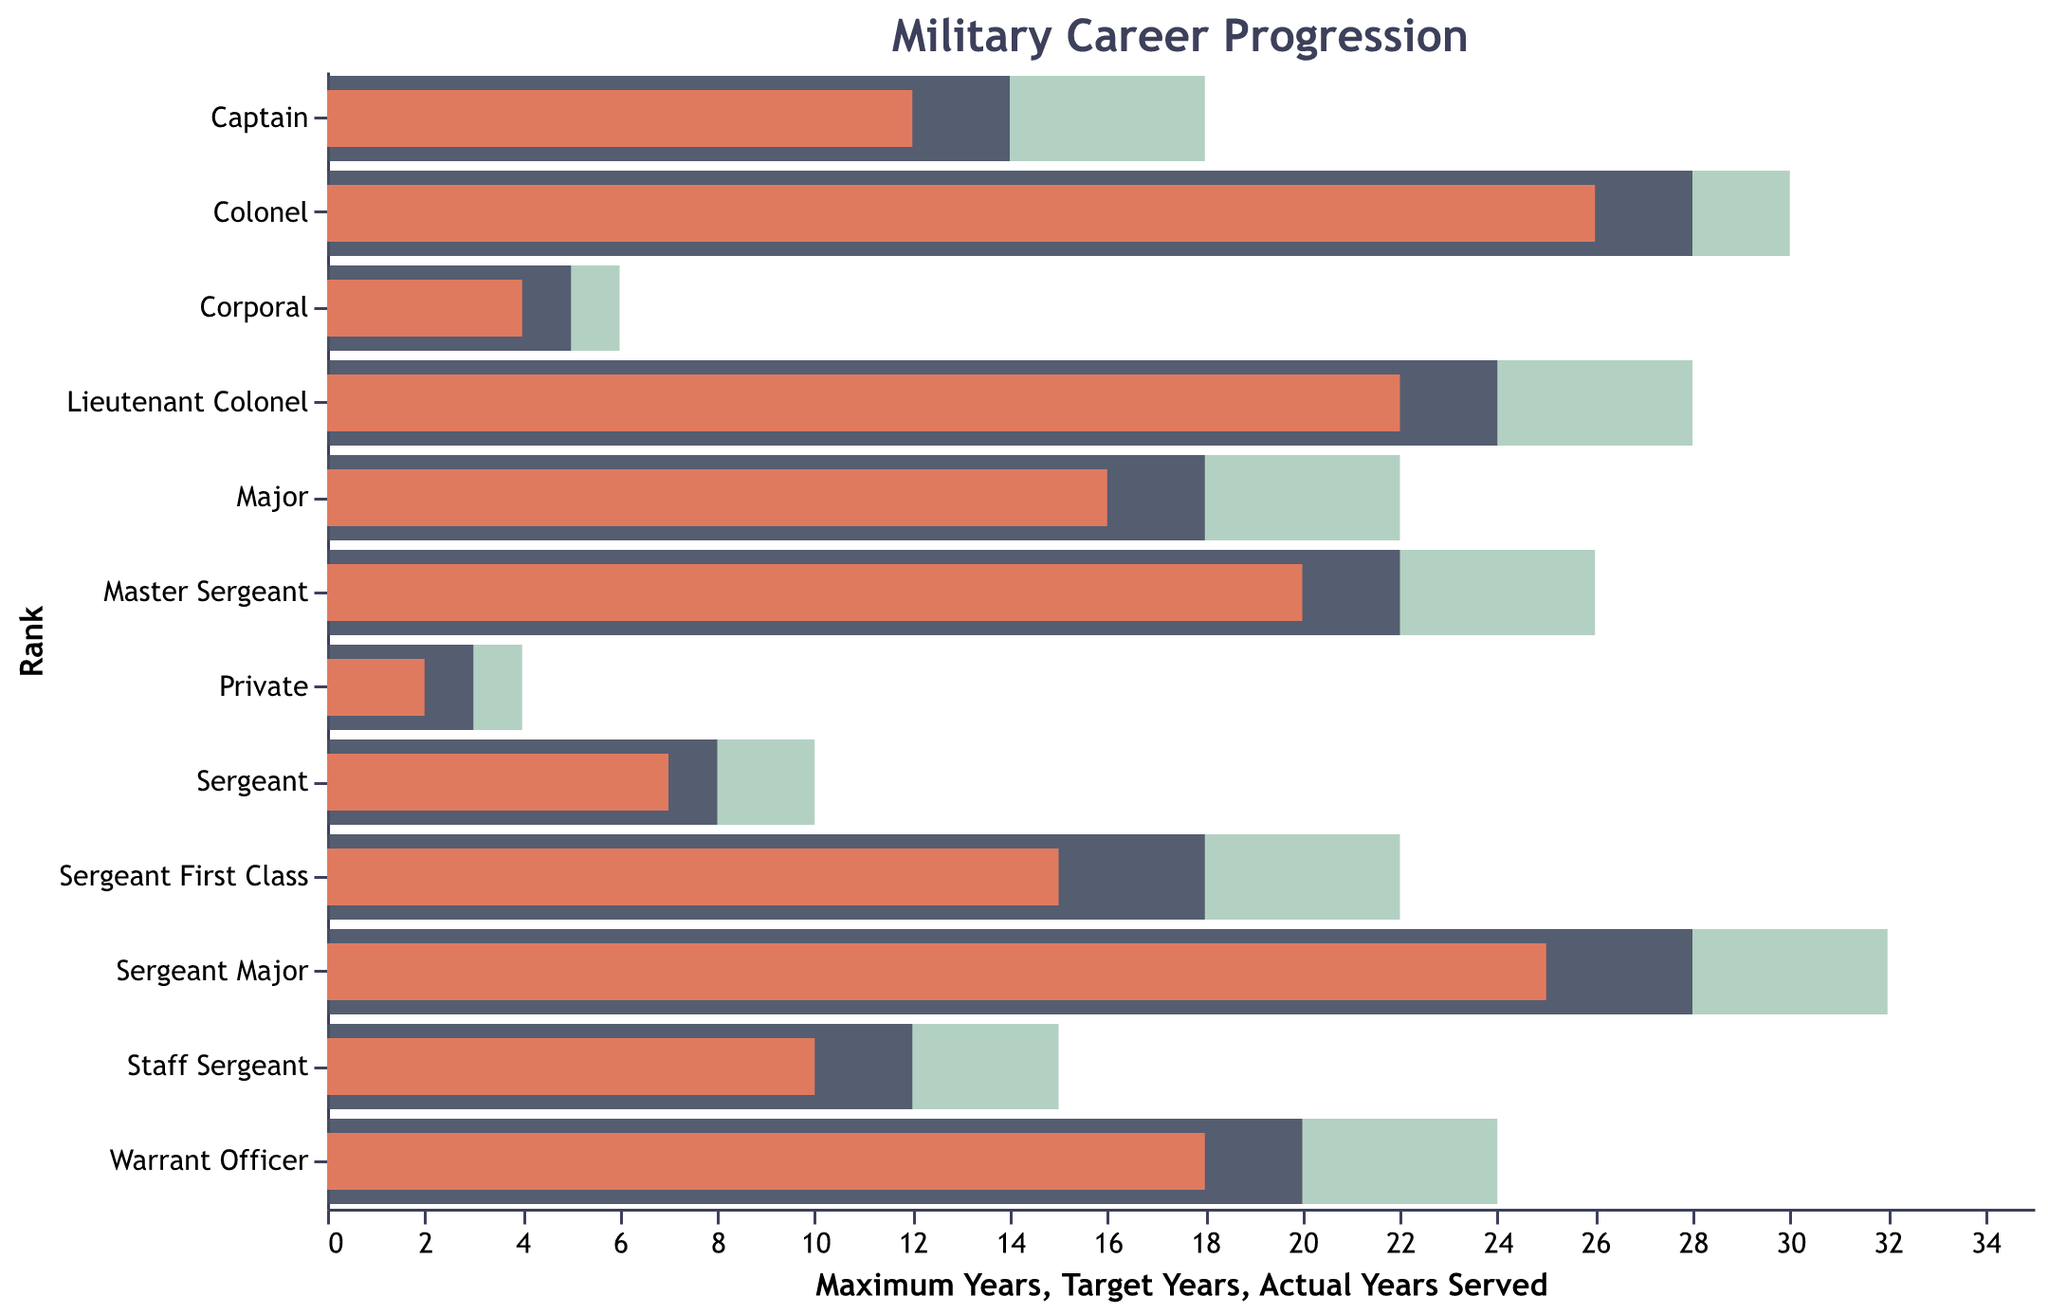What is the title of the chart? The title "Military Career Progression" is clearly displayed at the top of the chart in a larger font size.
Answer: Military Career Progression Which rank has the highest number of actual years served? The bar with the "Actual Years Served" value that stretches the farthest to the right represents the rank with the highest actual years served. For "Sergeant Major," the chart shows 25 years.
Answer: Sergeant Major What are the target years for a Major? Locate the "Major" row and find the length of the "Target Years" bar, which is marked by a darker shaded bar. For Major, it is 18 years.
Answer: 18 years How many actual years served does a Captain have, and how does it compare to its target years? Locate the "Captain" row, check the actual years served bar (12 years), and compare it with the target years bar (14 years).
Answer: Actual: 12 years, Target: 14 years How many ranks have more actual years served than their target years? Identify each rank where the "Actual Years Served" bar extends beyond the "Target Years" bar. These ranks are: Private, Corporal, and Sergeant.
Answer: 3 ranks Difference in years between the target and maximum years for Sergeant First Class? Subtract the target years from maximum years for "Sergeant First Class" (22 years - 18 years).
Answer: 4 years Which rank has the smallest difference between actual years served and target years? Compare the differences for each rank. "Private" has the smallest difference of 1 year (3 - 2 years).
Answer: Private What is the range of maximum years served within these ranks? Find the minimum and maximum values of "Maximum Years" across all ranks, which are 4 years (Private) and 32 years (Sergeant Major). The range is 32 - 4.
Answer: 28 years Does any rank have their actual years served equal to their target years? Check if any of the "Actual Years Served" bars align exactly with the "Target Years" bars. None of the ranks meet this criterion.
Answer: No Which rank has the highest maximum years, and how many years is it? Locate the tallest "Maximum Years" bar in the chart, for "Sergeant Major," indicating the highest maximum years served at 32 years.
Answer: Sergeant Major, 32 years 